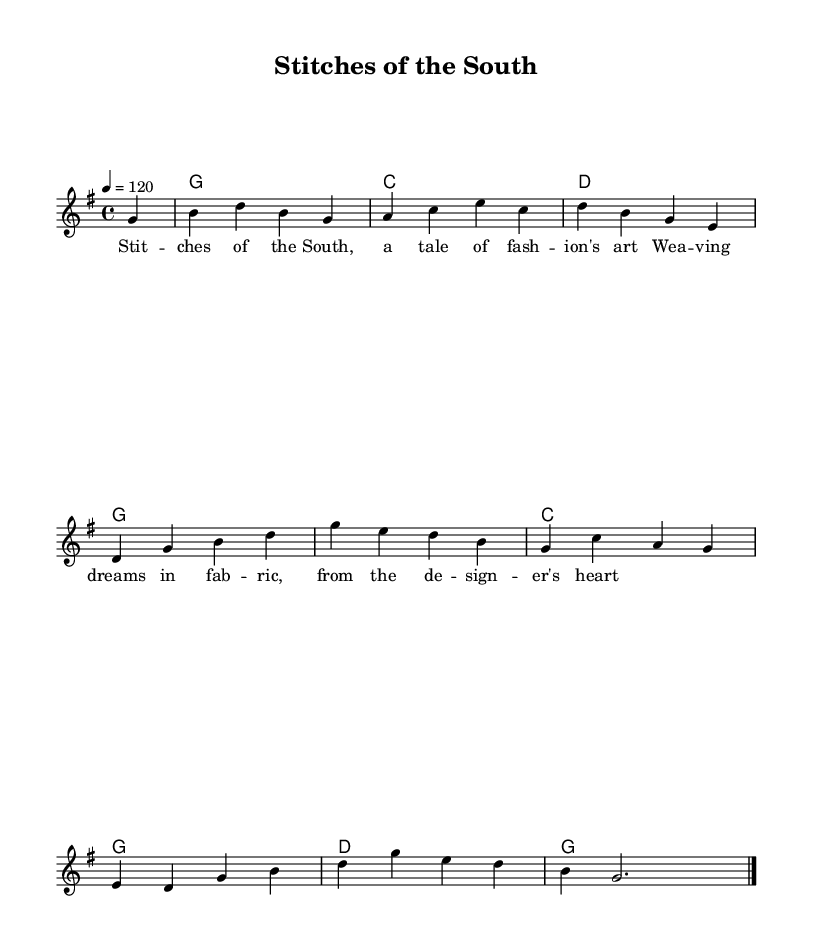What is the key signature of this music? The key signature is G major, which has one sharp (F#). This can be identified by looking at the key signature at the beginning of the staff.
Answer: G major What is the time signature of this piece? The time signature is 4/4, which means there are four beats in each measure. This is indicated at the beginning of the sheet music.
Answer: 4/4 What is the tempo marking of this piece? The tempo marking is 120 beats per minute, as indicated by the "4 = 120" annotation. This shows the speed at which the music should be played.
Answer: 120 How many measures are in the melody? The melody contains 8 measures, which can be counted by looking at the vertical lines (bar lines) that separate each measure.
Answer: 8 What chord follows the G major chord in the harmonies? The chord that follows the G major chord in the harmonies is C major. This can be determined by observing the chord symbols written above the staff in the harmonies section.
Answer: C What is the lyrical theme of this piece? The lyrical theme reflects fashion design and artistry, as indicated by the lyrics "Stitches of the South, a tale of fashion's art." This highlights the connection to the fashion industry.
Answer: Fashion design What is the form of the piece based on the lyrics? The form of the piece can be categorized as verse-chorus, as it consists of lyrical verses that convey a narrative. This is a common structure in country rock music, emphasizing storytelling.
Answer: Verse-chorus 